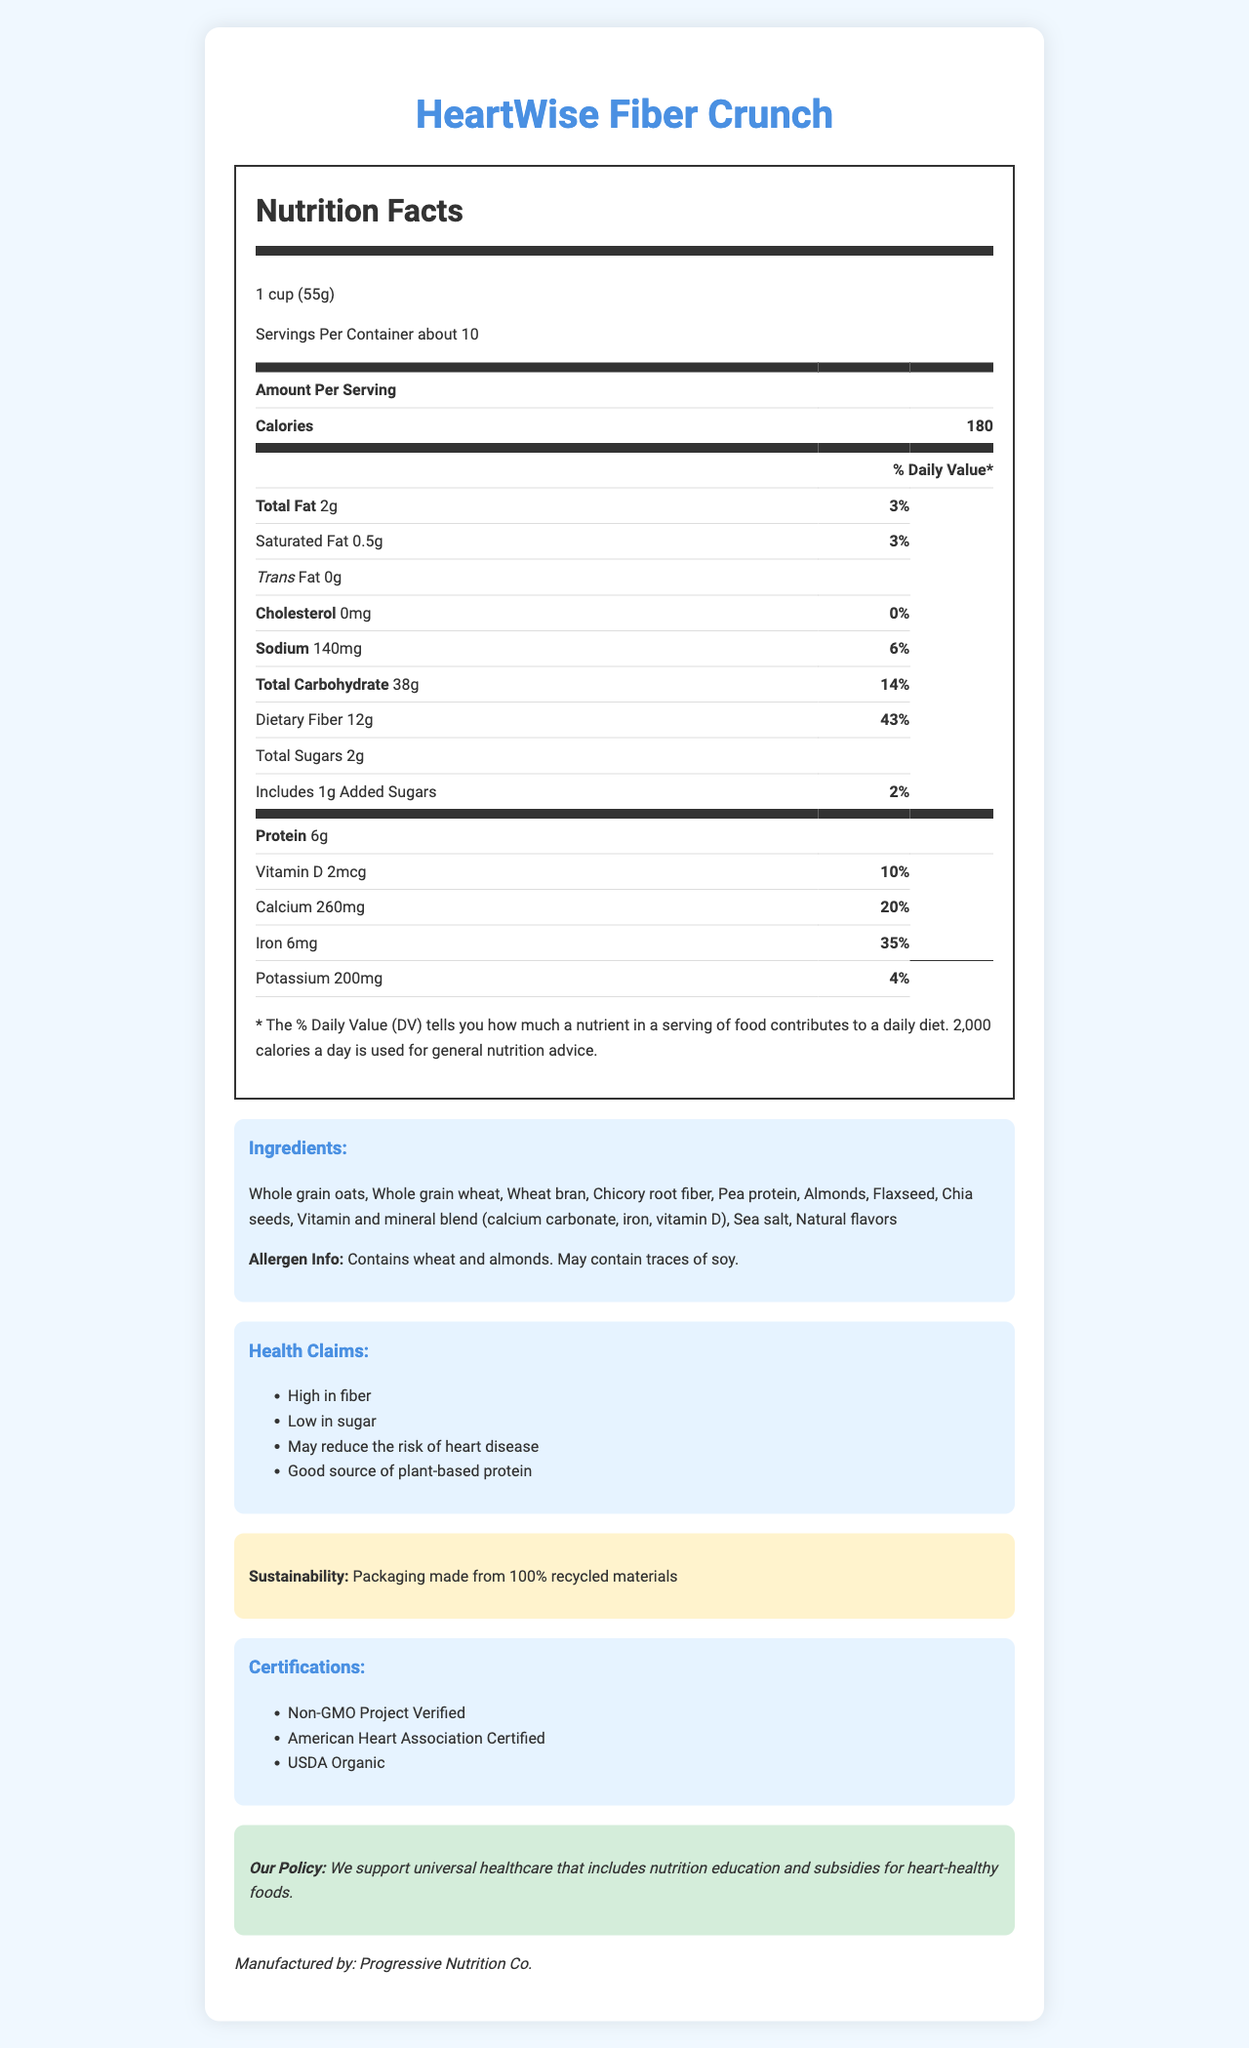what is the serving size for HeartWise Fiber Crunch? The document specifies the serving size as "1 cup (55g)".
Answer: 1 cup (55g) how many servings are there per container? The document states that there are "about 10" servings per container.
Answer: about 10 what is the amount of dietary fiber per serving? The document lists 12g of dietary fiber per serving.
Answer: 12g how much protein does one serving contain? The document indicates that one serving contains 6g of protein.
Answer: 6g what are the ingredients of HeartWise Fiber Crunch? The document provides the complete list of ingredients.
Answer: Whole grain oats, Whole grain wheat, Wheat bran, Chicory root fiber, Pea protein, Almonds, Flaxseed, Chia seeds, Vitamin and mineral blend (calcium carbonate, iron, vitamin D), Sea salt, Natural flavors how much added sugar is in a serving of HeartWise Fiber Crunch? The document states that there is 1g of added sugar per serving.
Answer: 1g what is the percent daily value of calcium per serving? The document states that the percent daily value of calcium per serving is 20%.
Answer: 20% which of the following certifications does HeartWise Fiber Crunch hold? (Choose all that apply) A. Non-GMO Project Verified B. American Heart Association Certified C. USDA Organic D. Certified Gluten-Free The document lists the certifications as "Non-GMO Project Verified", "American Heart Association Certified", and "USDA Organic".
Answer: A, B, C what health claims does this product make? (Choose one) 1. High performance 2. High in fiber 3. Weight loss guarantee The document makes the health claims, including "High in fiber".
Answer: 2 is HeartWise Fiber Crunch gluten-free? The document lists wheat as an ingredient, which contains gluten.
Answer: No do the ingredients list any allergens? The document states that it contains wheat and almonds and may contain traces of soy.
Answer: Yes briefly describe the main idea of this document. The explanation is based on the summary of the provided document information including nutritional facts, ingredients, health claims, sustainability info, and the policy statement.
Answer: The document provides detailed nutritional information, ingredients, health claims, and certifications for HeartWise Fiber Crunch, a low-sugar, high-fiber breakfast cereal promoted for its heart health benefits. It includes a policy statement from the manufacturer supporting universal healthcare with nutrition education. who is the manufacturer of HeartWise Fiber Crunch? The document names the manufacturer as "Progressive Nutrition Co."
Answer: Progressive Nutrition Co. is HeartWise Fiber Crunch certified organic? The document includes "USDA Organic" in the certifications section.
Answer: Yes how much sodium is there in one serving? The document lists the sodium content per serving as 140mg.
Answer: 140mg does the document provide any information about whether the product is vegan? The document does not explicitly state whether the product is vegan.
Answer: Not enough information how many calories are in one serving of HeartWise Fiber Crunch? The document lists the calorie count per serving as 180.
Answer: 180 what is the daily value percentage of dietary fiber in one serving? The document states that the daily value percentage for dietary fiber is 43%.
Answer: 43% does the product contain any trans fat? The document mentions that the product contains 0g trans fat.
Answer: No 